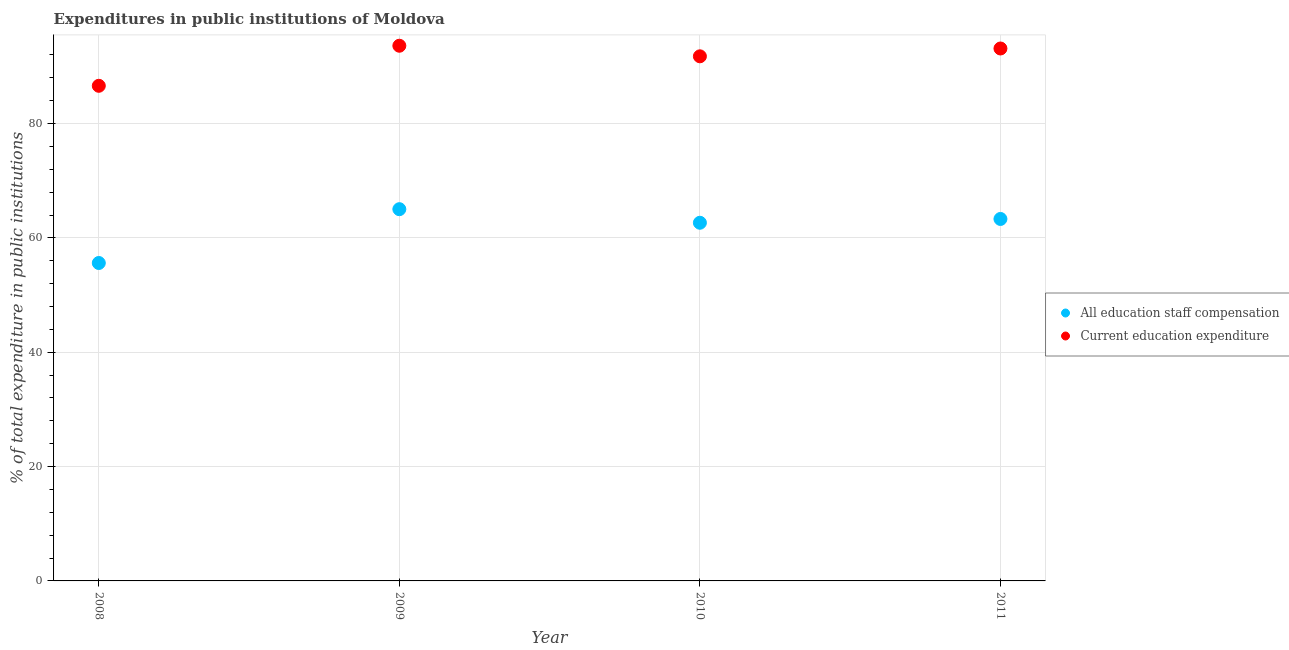What is the expenditure in staff compensation in 2011?
Make the answer very short. 63.31. Across all years, what is the maximum expenditure in education?
Give a very brief answer. 93.61. Across all years, what is the minimum expenditure in education?
Provide a short and direct response. 86.6. What is the total expenditure in education in the graph?
Keep it short and to the point. 365.1. What is the difference between the expenditure in education in 2009 and that in 2011?
Offer a very short reply. 0.48. What is the difference between the expenditure in education in 2011 and the expenditure in staff compensation in 2009?
Ensure brevity in your answer.  28.11. What is the average expenditure in staff compensation per year?
Ensure brevity in your answer.  61.65. In the year 2008, what is the difference between the expenditure in staff compensation and expenditure in education?
Offer a terse response. -30.99. What is the ratio of the expenditure in staff compensation in 2009 to that in 2011?
Provide a succinct answer. 1.03. Is the difference between the expenditure in staff compensation in 2010 and 2011 greater than the difference between the expenditure in education in 2010 and 2011?
Ensure brevity in your answer.  Yes. What is the difference between the highest and the second highest expenditure in staff compensation?
Provide a short and direct response. 1.71. What is the difference between the highest and the lowest expenditure in education?
Provide a succinct answer. 7.01. Is the sum of the expenditure in staff compensation in 2008 and 2010 greater than the maximum expenditure in education across all years?
Your response must be concise. Yes. Does the expenditure in staff compensation monotonically increase over the years?
Provide a succinct answer. No. Is the expenditure in staff compensation strictly less than the expenditure in education over the years?
Offer a terse response. Yes. What is the difference between two consecutive major ticks on the Y-axis?
Your response must be concise. 20. Does the graph contain grids?
Ensure brevity in your answer.  Yes. How are the legend labels stacked?
Provide a succinct answer. Vertical. What is the title of the graph?
Your answer should be compact. Expenditures in public institutions of Moldova. What is the label or title of the X-axis?
Your response must be concise. Year. What is the label or title of the Y-axis?
Keep it short and to the point. % of total expenditure in public institutions. What is the % of total expenditure in public institutions in All education staff compensation in 2008?
Your response must be concise. 55.61. What is the % of total expenditure in public institutions in Current education expenditure in 2008?
Ensure brevity in your answer.  86.6. What is the % of total expenditure in public institutions of All education staff compensation in 2009?
Your answer should be compact. 65.02. What is the % of total expenditure in public institutions of Current education expenditure in 2009?
Ensure brevity in your answer.  93.61. What is the % of total expenditure in public institutions of All education staff compensation in 2010?
Provide a short and direct response. 62.65. What is the % of total expenditure in public institutions in Current education expenditure in 2010?
Give a very brief answer. 91.76. What is the % of total expenditure in public institutions in All education staff compensation in 2011?
Offer a very short reply. 63.31. What is the % of total expenditure in public institutions in Current education expenditure in 2011?
Offer a terse response. 93.13. Across all years, what is the maximum % of total expenditure in public institutions in All education staff compensation?
Provide a short and direct response. 65.02. Across all years, what is the maximum % of total expenditure in public institutions in Current education expenditure?
Offer a very short reply. 93.61. Across all years, what is the minimum % of total expenditure in public institutions in All education staff compensation?
Your response must be concise. 55.61. Across all years, what is the minimum % of total expenditure in public institutions of Current education expenditure?
Your answer should be compact. 86.6. What is the total % of total expenditure in public institutions in All education staff compensation in the graph?
Offer a very short reply. 246.59. What is the total % of total expenditure in public institutions in Current education expenditure in the graph?
Offer a very short reply. 365.1. What is the difference between the % of total expenditure in public institutions of All education staff compensation in 2008 and that in 2009?
Provide a succinct answer. -9.41. What is the difference between the % of total expenditure in public institutions of Current education expenditure in 2008 and that in 2009?
Offer a very short reply. -7.01. What is the difference between the % of total expenditure in public institutions in All education staff compensation in 2008 and that in 2010?
Provide a short and direct response. -7.04. What is the difference between the % of total expenditure in public institutions of Current education expenditure in 2008 and that in 2010?
Your response must be concise. -5.16. What is the difference between the % of total expenditure in public institutions in All education staff compensation in 2008 and that in 2011?
Provide a succinct answer. -7.7. What is the difference between the % of total expenditure in public institutions in Current education expenditure in 2008 and that in 2011?
Keep it short and to the point. -6.53. What is the difference between the % of total expenditure in public institutions in All education staff compensation in 2009 and that in 2010?
Make the answer very short. 2.37. What is the difference between the % of total expenditure in public institutions in Current education expenditure in 2009 and that in 2010?
Your response must be concise. 1.85. What is the difference between the % of total expenditure in public institutions of All education staff compensation in 2009 and that in 2011?
Offer a terse response. 1.71. What is the difference between the % of total expenditure in public institutions in Current education expenditure in 2009 and that in 2011?
Give a very brief answer. 0.48. What is the difference between the % of total expenditure in public institutions of All education staff compensation in 2010 and that in 2011?
Your answer should be compact. -0.66. What is the difference between the % of total expenditure in public institutions in Current education expenditure in 2010 and that in 2011?
Provide a short and direct response. -1.37. What is the difference between the % of total expenditure in public institutions in All education staff compensation in 2008 and the % of total expenditure in public institutions in Current education expenditure in 2009?
Offer a very short reply. -38. What is the difference between the % of total expenditure in public institutions of All education staff compensation in 2008 and the % of total expenditure in public institutions of Current education expenditure in 2010?
Your answer should be very brief. -36.15. What is the difference between the % of total expenditure in public institutions of All education staff compensation in 2008 and the % of total expenditure in public institutions of Current education expenditure in 2011?
Provide a succinct answer. -37.52. What is the difference between the % of total expenditure in public institutions in All education staff compensation in 2009 and the % of total expenditure in public institutions in Current education expenditure in 2010?
Your answer should be compact. -26.74. What is the difference between the % of total expenditure in public institutions in All education staff compensation in 2009 and the % of total expenditure in public institutions in Current education expenditure in 2011?
Provide a short and direct response. -28.11. What is the difference between the % of total expenditure in public institutions of All education staff compensation in 2010 and the % of total expenditure in public institutions of Current education expenditure in 2011?
Offer a very short reply. -30.48. What is the average % of total expenditure in public institutions in All education staff compensation per year?
Offer a terse response. 61.65. What is the average % of total expenditure in public institutions in Current education expenditure per year?
Offer a terse response. 91.28. In the year 2008, what is the difference between the % of total expenditure in public institutions in All education staff compensation and % of total expenditure in public institutions in Current education expenditure?
Provide a succinct answer. -30.99. In the year 2009, what is the difference between the % of total expenditure in public institutions of All education staff compensation and % of total expenditure in public institutions of Current education expenditure?
Keep it short and to the point. -28.59. In the year 2010, what is the difference between the % of total expenditure in public institutions in All education staff compensation and % of total expenditure in public institutions in Current education expenditure?
Your answer should be compact. -29.11. In the year 2011, what is the difference between the % of total expenditure in public institutions of All education staff compensation and % of total expenditure in public institutions of Current education expenditure?
Your answer should be compact. -29.82. What is the ratio of the % of total expenditure in public institutions in All education staff compensation in 2008 to that in 2009?
Ensure brevity in your answer.  0.86. What is the ratio of the % of total expenditure in public institutions in Current education expenditure in 2008 to that in 2009?
Provide a short and direct response. 0.93. What is the ratio of the % of total expenditure in public institutions in All education staff compensation in 2008 to that in 2010?
Provide a short and direct response. 0.89. What is the ratio of the % of total expenditure in public institutions in Current education expenditure in 2008 to that in 2010?
Provide a succinct answer. 0.94. What is the ratio of the % of total expenditure in public institutions in All education staff compensation in 2008 to that in 2011?
Offer a very short reply. 0.88. What is the ratio of the % of total expenditure in public institutions of Current education expenditure in 2008 to that in 2011?
Provide a short and direct response. 0.93. What is the ratio of the % of total expenditure in public institutions in All education staff compensation in 2009 to that in 2010?
Your answer should be compact. 1.04. What is the ratio of the % of total expenditure in public institutions in Current education expenditure in 2009 to that in 2010?
Provide a short and direct response. 1.02. What is the ratio of the % of total expenditure in public institutions of Current education expenditure in 2009 to that in 2011?
Your answer should be very brief. 1.01. What is the difference between the highest and the second highest % of total expenditure in public institutions in All education staff compensation?
Offer a very short reply. 1.71. What is the difference between the highest and the second highest % of total expenditure in public institutions of Current education expenditure?
Give a very brief answer. 0.48. What is the difference between the highest and the lowest % of total expenditure in public institutions of All education staff compensation?
Offer a very short reply. 9.41. What is the difference between the highest and the lowest % of total expenditure in public institutions of Current education expenditure?
Your response must be concise. 7.01. 